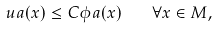Convert formula to latex. <formula><loc_0><loc_0><loc_500><loc_500>\ u a ( x ) \leq C \phi a ( x ) \quad \forall x \in M ,</formula> 